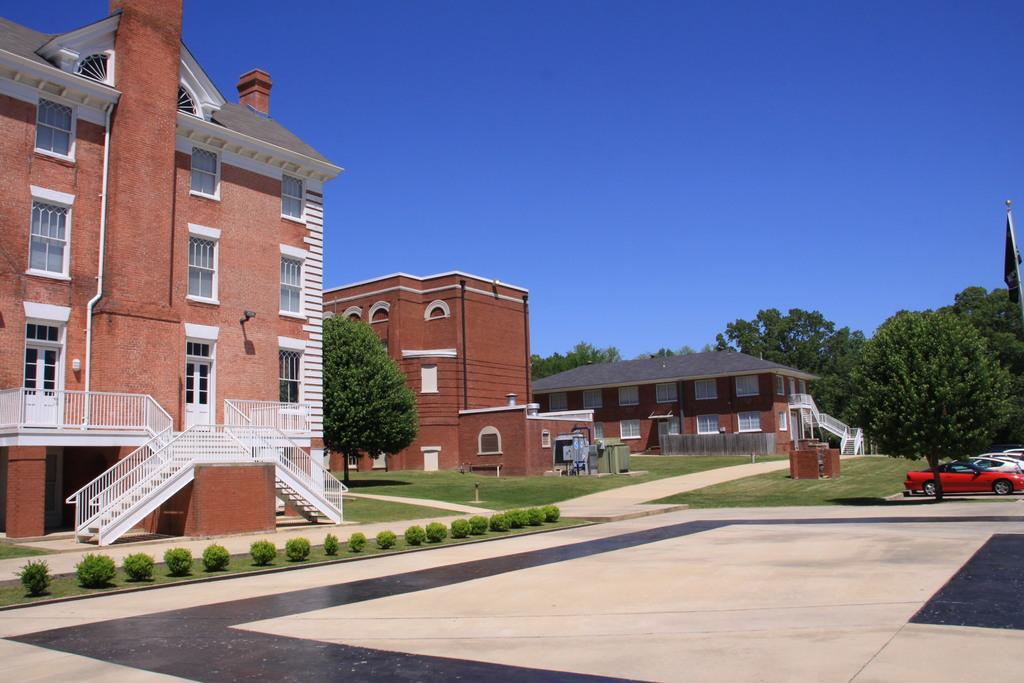How would you summarize this image in a sentence or two? This picture is clicked outside the city. On the left side of the picture, we see a building in white and brown color. Beside that, we see a staircase and stair railing. Beside that, there are shrubs. In the middle of the picture, we see buildings in brown color. Beside that, there are trees. On the right side, we see cars parked on the road and we even see the trees. There are trees in the background. At the top of the picture, we see the sky, which is blue in color. 